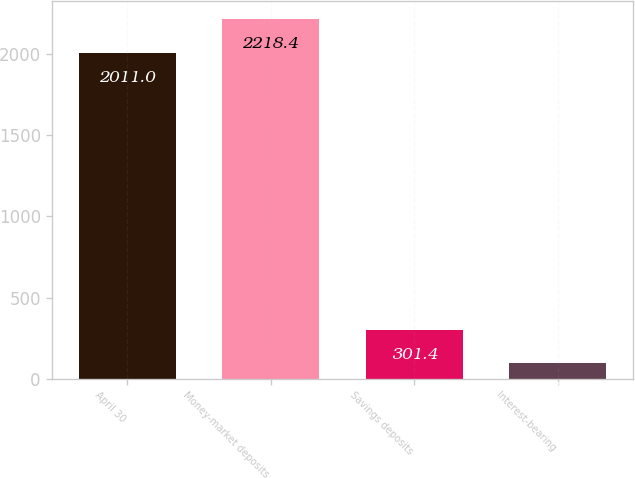Convert chart. <chart><loc_0><loc_0><loc_500><loc_500><bar_chart><fcel>April 30<fcel>Money-market deposits<fcel>Savings deposits<fcel>Interest-bearing<nl><fcel>2011<fcel>2218.4<fcel>301.4<fcel>94<nl></chart> 